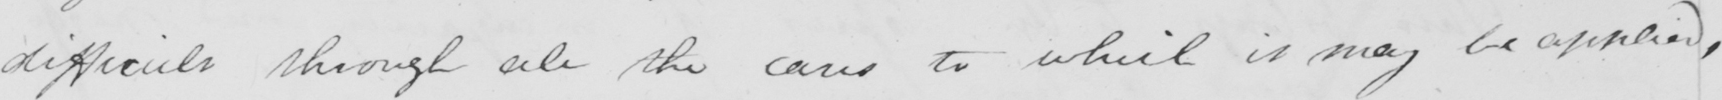Can you tell me what this handwritten text says? difficult through all the cares to which it may be applied , 